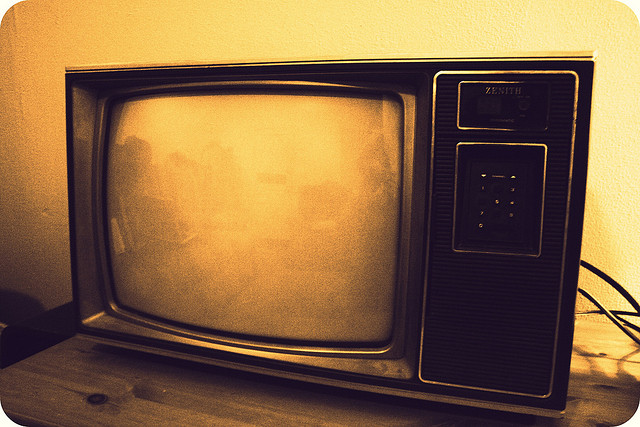<image>What is the brand name of the television? The brand name of the television is unknown. It could be Zenith, Sony, RCA, or Panasonic. What is the brand name of the television? I don't know the brand name of the television. It can be Zenith, Sony, RCA, or Panasonic. 